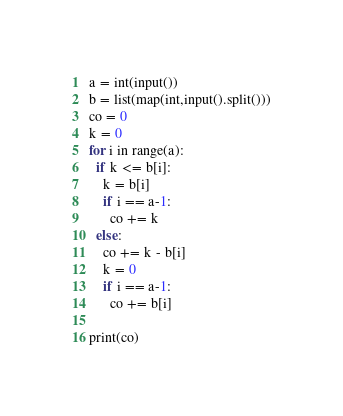<code> <loc_0><loc_0><loc_500><loc_500><_Python_>a = int(input())
b = list(map(int,input().split()))
co = 0
k = 0
for i in range(a):
  if k <= b[i]:
    k = b[i]
    if i == a-1:
      co += k
  else:
    co += k - b[i]
    k = 0
    if i == a-1:
      co += b[i]
    
print(co)</code> 